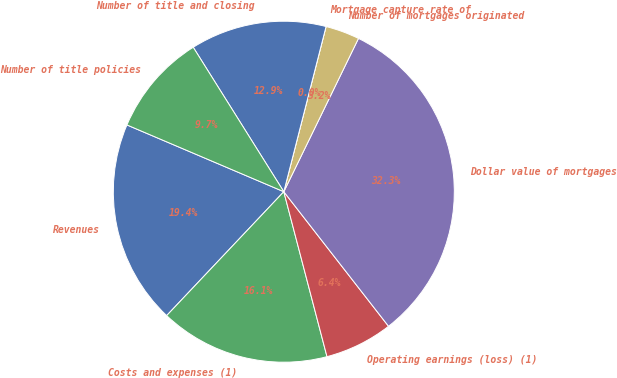<chart> <loc_0><loc_0><loc_500><loc_500><pie_chart><fcel>Revenues<fcel>Costs and expenses (1)<fcel>Operating earnings (loss) (1)<fcel>Dollar value of mortgages<fcel>Number of mortgages originated<fcel>Mortgage capture rate of<fcel>Number of title and closing<fcel>Number of title policies<nl><fcel>19.35%<fcel>16.13%<fcel>6.45%<fcel>32.26%<fcel>3.23%<fcel>0.0%<fcel>12.9%<fcel>9.68%<nl></chart> 